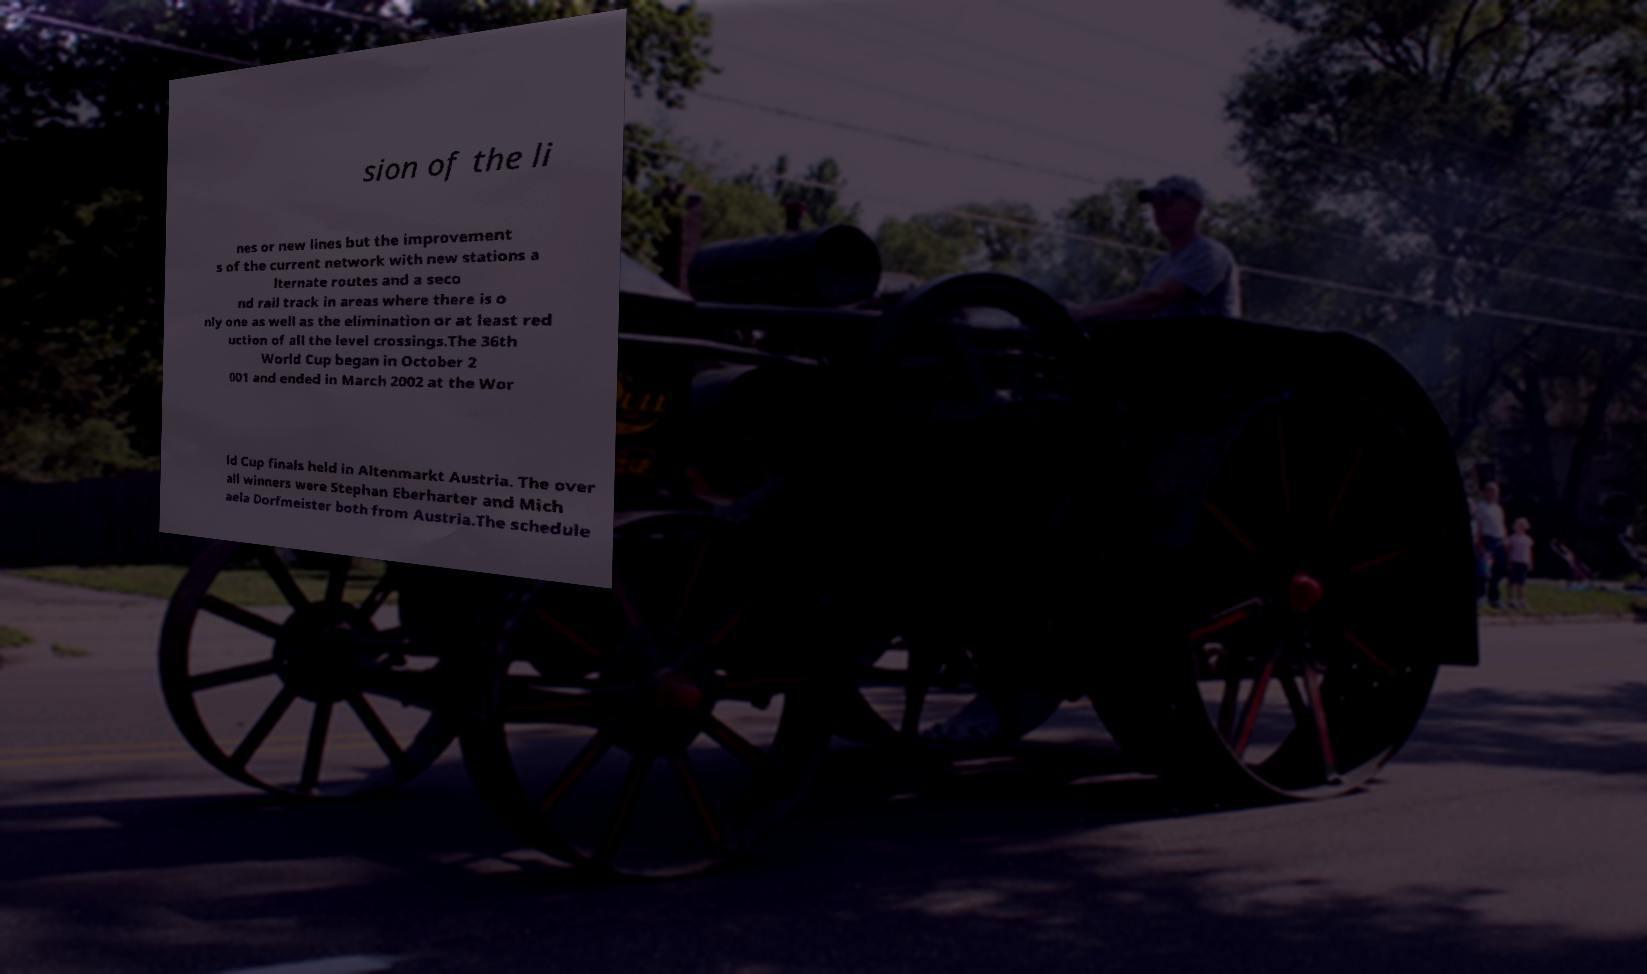Can you accurately transcribe the text from the provided image for me? sion of the li nes or new lines but the improvement s of the current network with new stations a lternate routes and a seco nd rail track in areas where there is o nly one as well as the elimination or at least red uction of all the level crossings.The 36th World Cup began in October 2 001 and ended in March 2002 at the Wor ld Cup finals held in Altenmarkt Austria. The over all winners were Stephan Eberharter and Mich aela Dorfmeister both from Austria.The schedule 